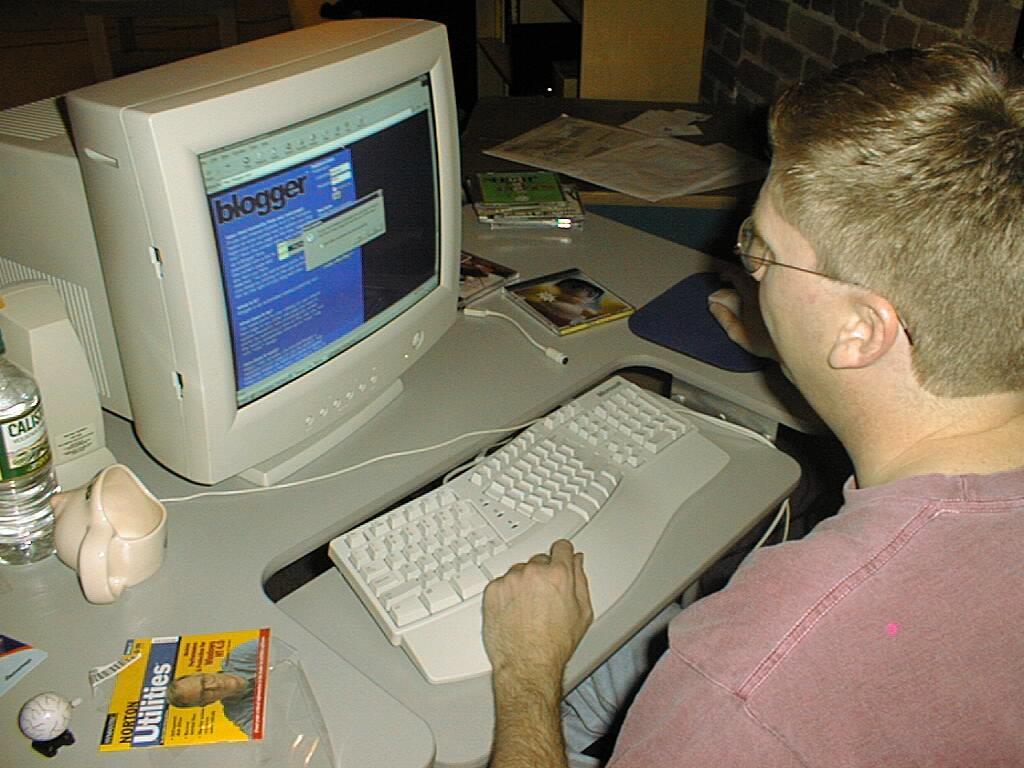Could you give a brief overview of what you see in this image? In this image I can see a person holding a mouse. In front I can see a system,keyboard,bottle,cup,papers and few objects on the table. Back I can see a brick wall. 